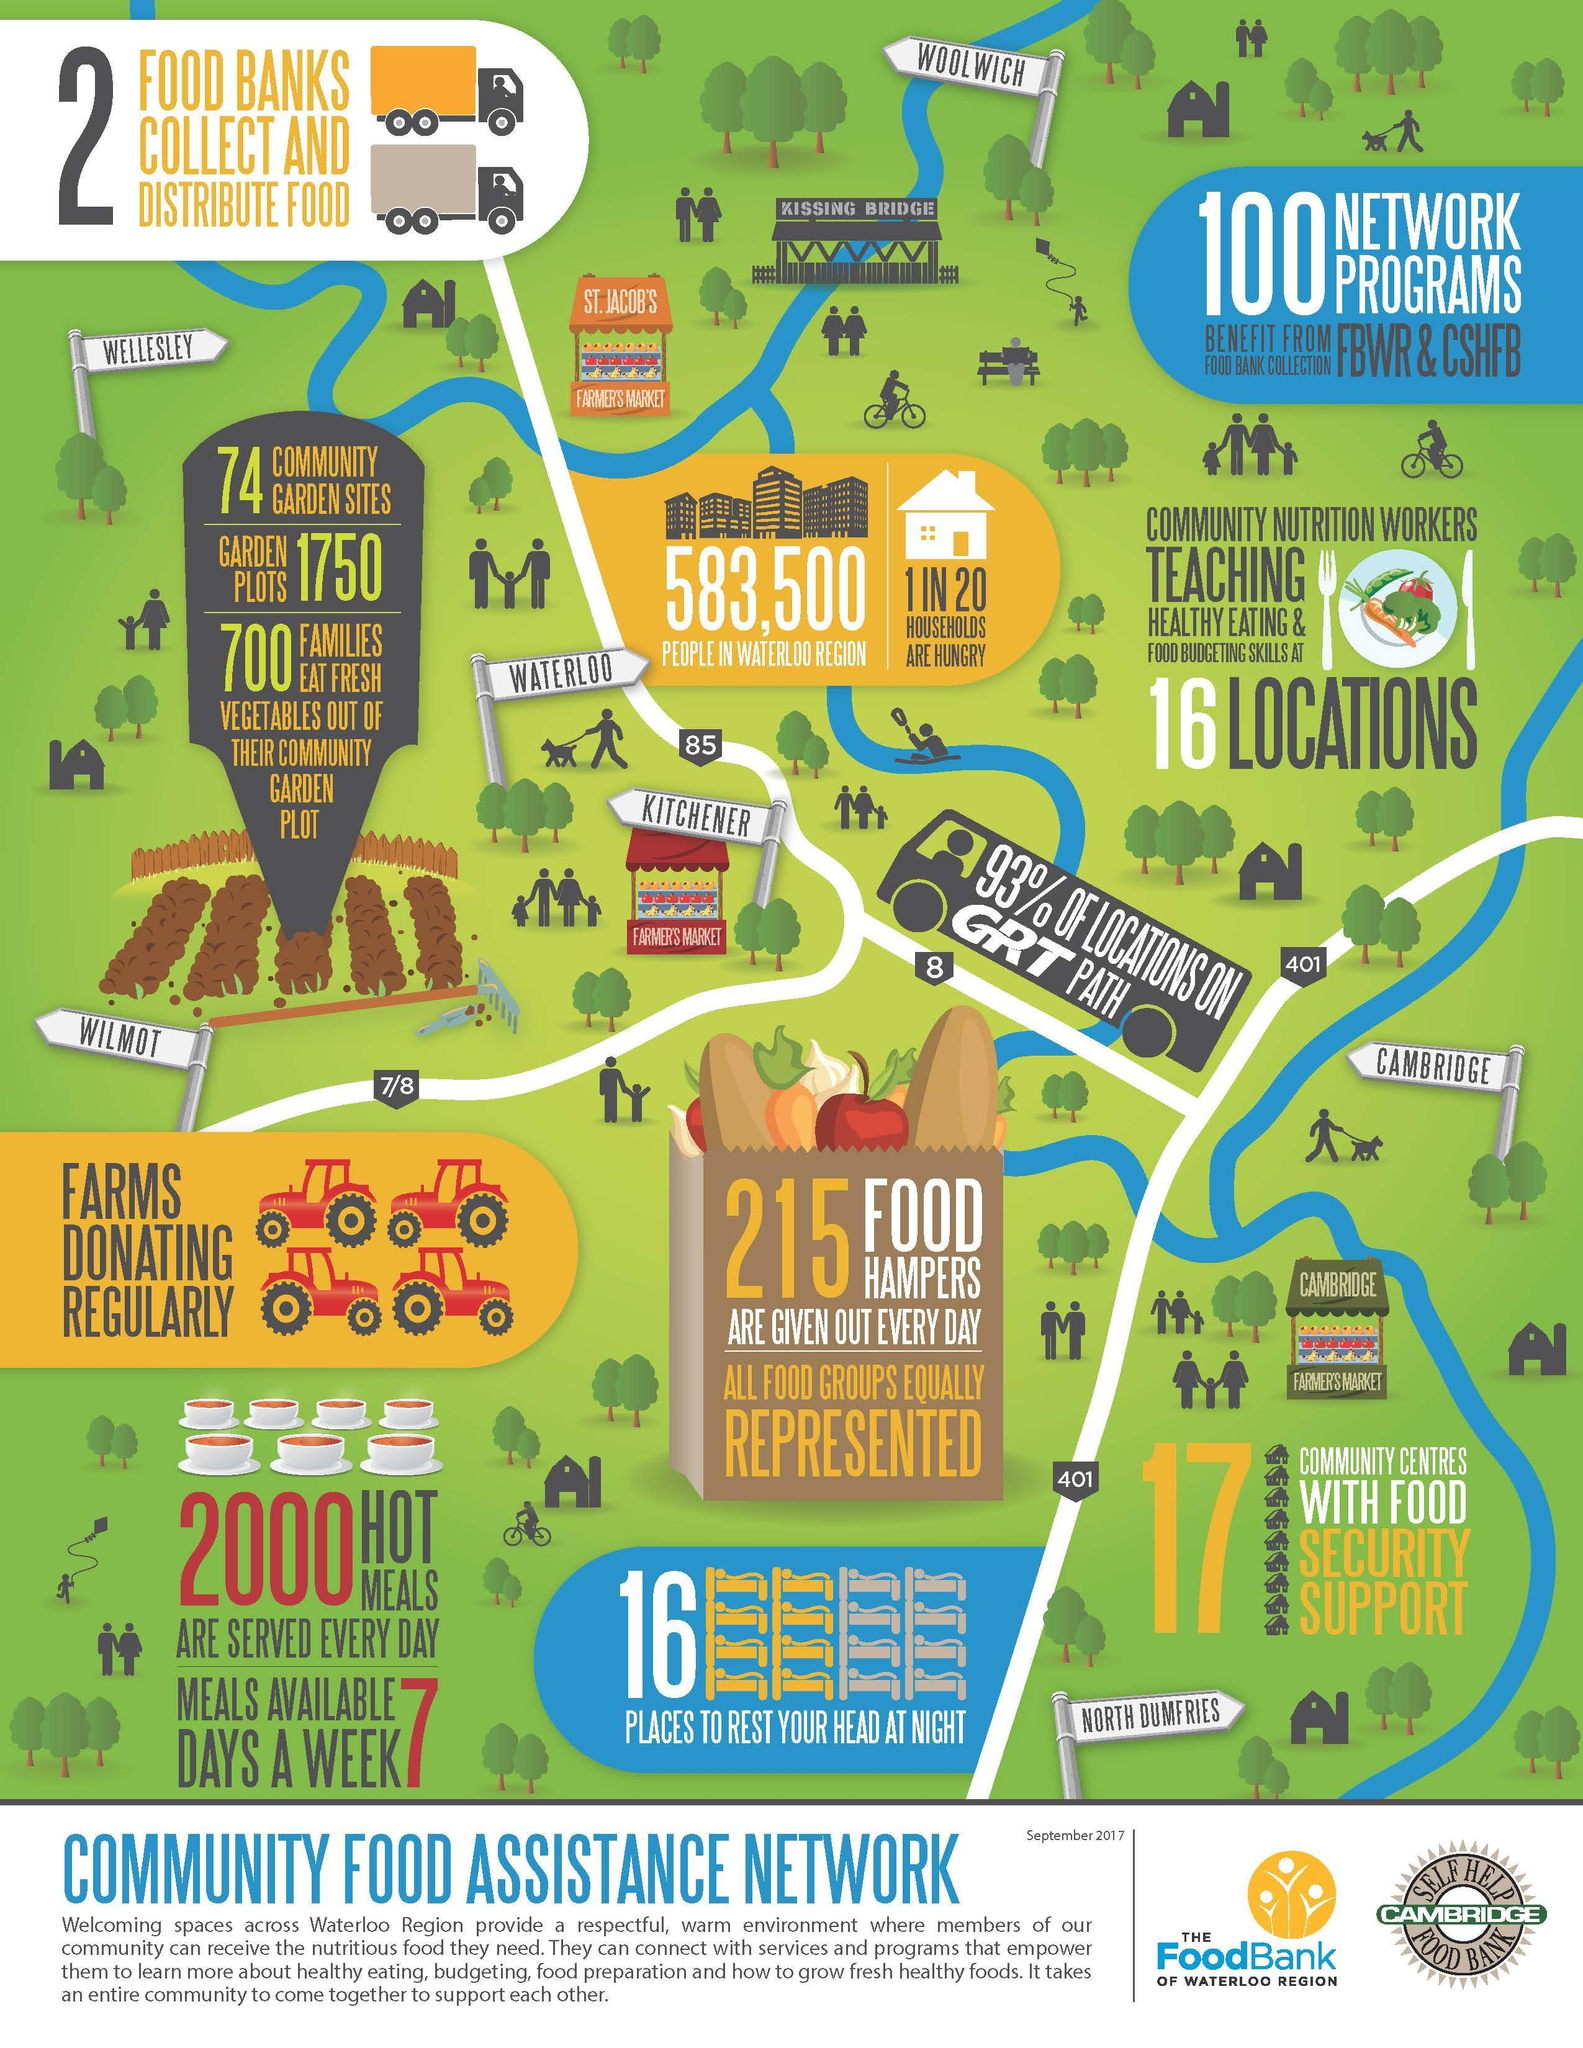How many farmers markets is shown in the image?
Answer the question with a short phrase. 3 